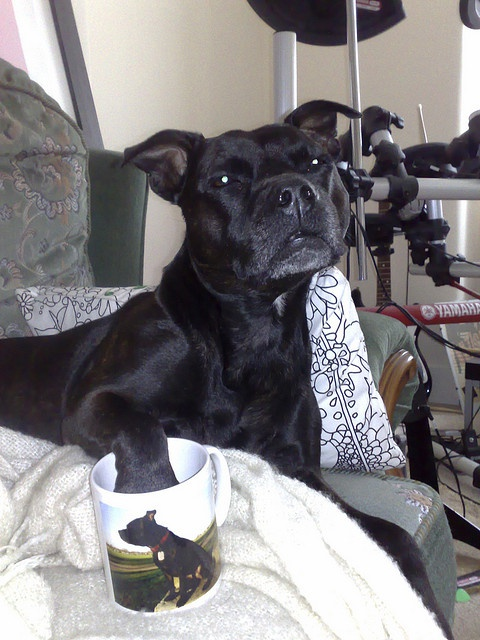Describe the objects in this image and their specific colors. I can see dog in pink, black, and gray tones, chair in pink, gray, darkgray, lavender, and black tones, bicycle in pink, black, gray, and darkgray tones, cup in pink, white, gray, darkgray, and black tones, and dog in pink, gray, and black tones in this image. 